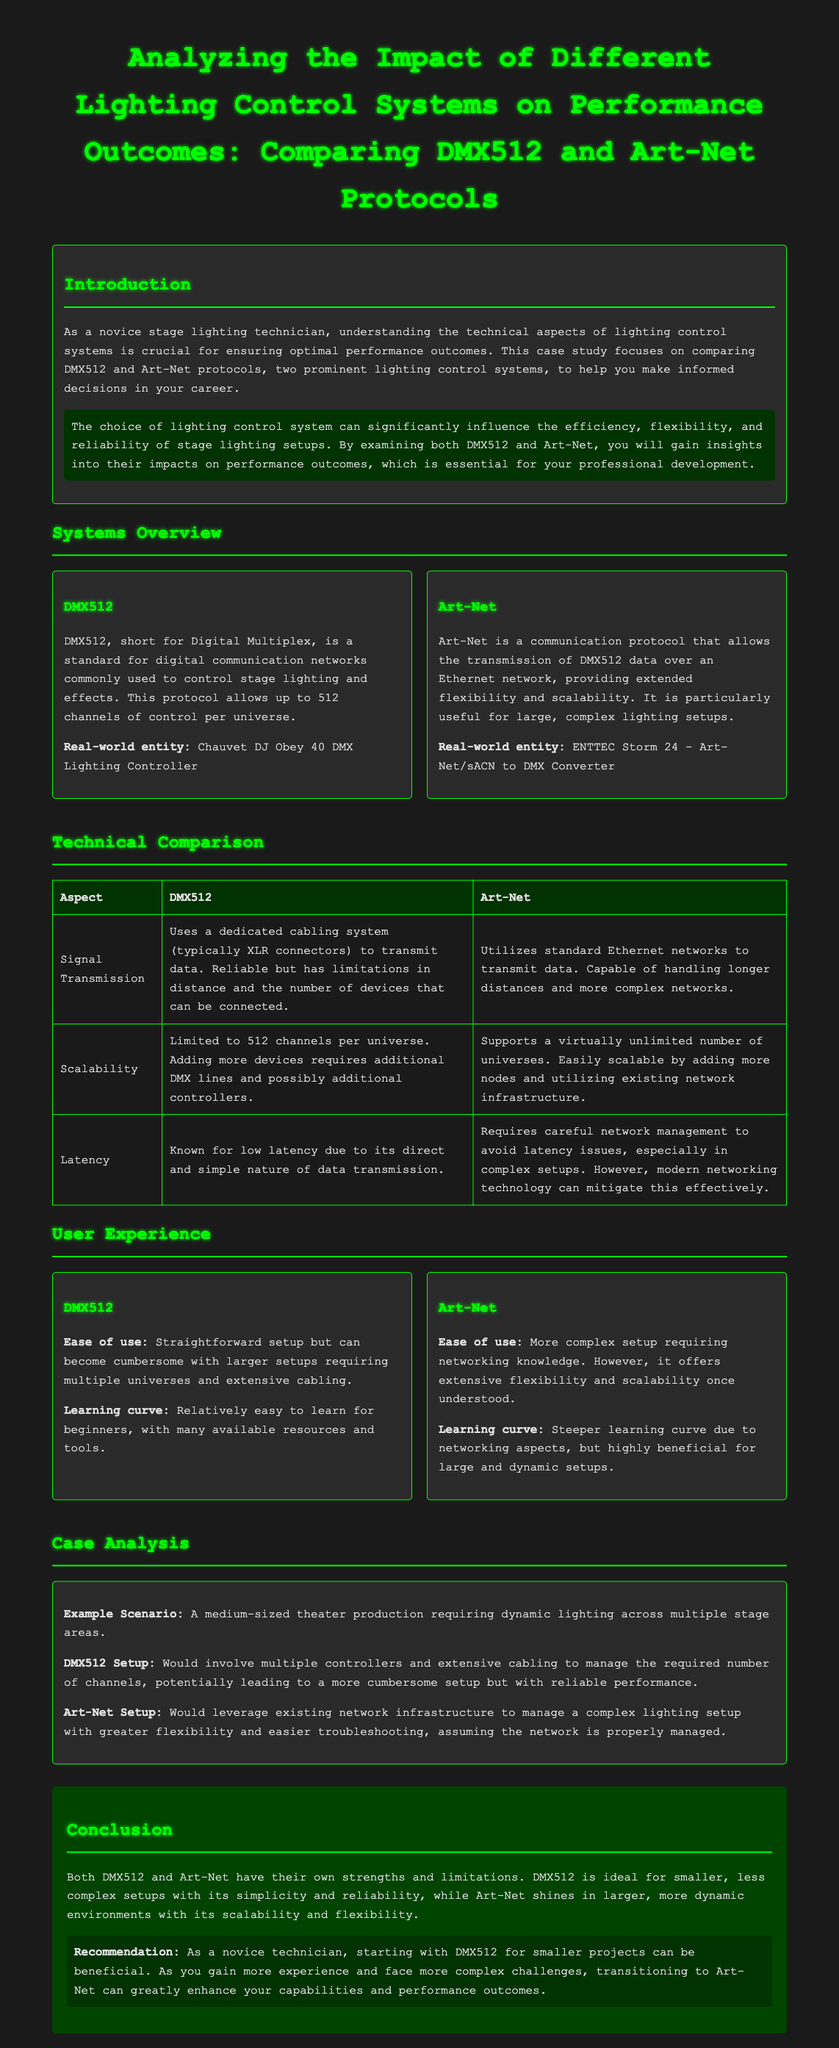What does DMX512 stand for? DMX512 is short for Digital Multiplex, which is mentioned in the document's overview of DMX512.
Answer: Digital Multiplex How many channels does DMX512 allow per universe? The document states that DMX512 allows up to 512 channels of control per universe.
Answer: 512 channels What is the primary real-world entity associated with Art-Net? The document lists the ENTTEC Storm 24 - Art-Net/sACN to DMX Converter as the real-world entity associated with Art-Net.
Answer: ENTTEC Storm 24 - Art-Net/sACN to DMX Converter Which protocol is known for its low latency? The document indicates DMX512 is known for low latency due to its direct data transmission.
Answer: DMX512 What is a key recommendation for novice technicians in the document? The conclusion section recommends starting with DMX512 for smaller projects for novice technicians.
Answer: DMX512 What does Art-Net utilize for data transmission? The document specifies that Art-Net utilizes standard Ethernet networks to transmit data.
Answer: Standard Ethernet networks What is a primary advantage of Art-Net mentioned in the technical comparison? The document states that Art-Net supports a virtually unlimited number of universes, highlighting its scalability.
Answer: Virtually unlimited number of universes What is the main drawback of DMX512 in larger setups? The document mentions that DMX512 can become cumbersome with larger setups requiring multiple universes and extensive cabling.
Answer: Cumbersome setup Which protocol requires careful network management to avoid latency issues? According to the document, Art-Net requires careful network management to avoid latency issues, especially in complex setups.
Answer: Art-Net 